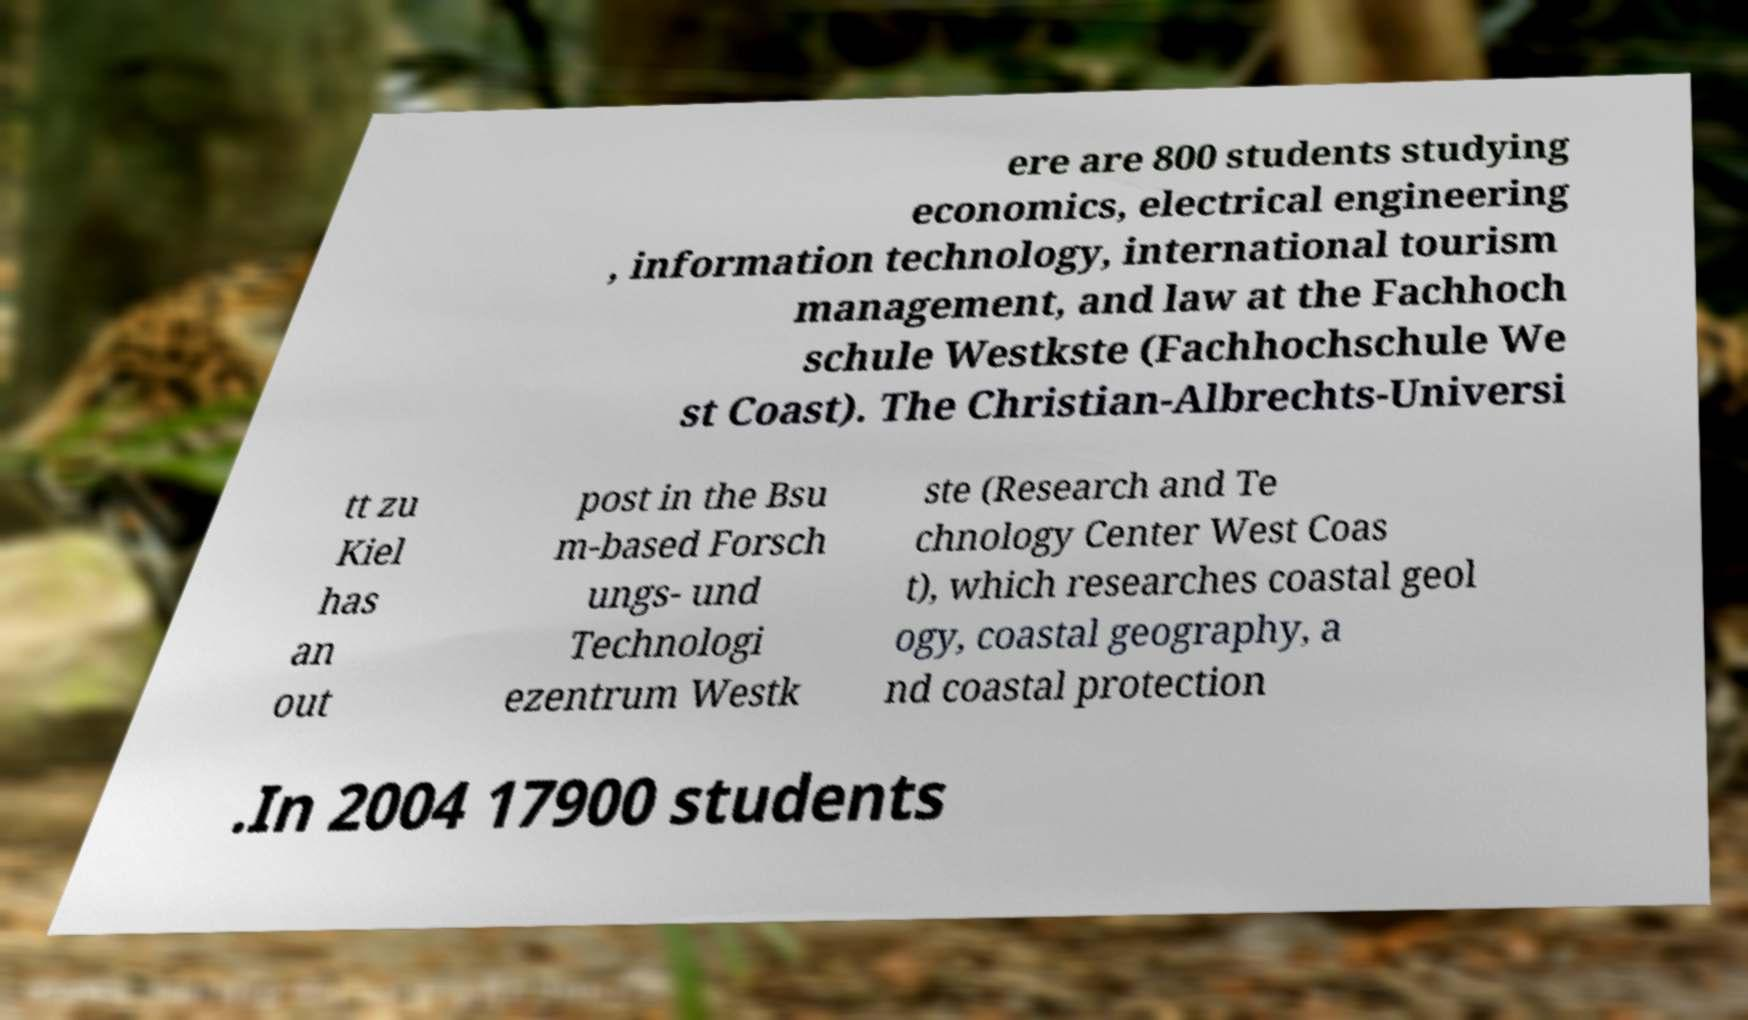Please read and relay the text visible in this image. What does it say? ere are 800 students studying economics, electrical engineering , information technology, international tourism management, and law at the Fachhoch schule Westkste (Fachhochschule We st Coast). The Christian-Albrechts-Universi tt zu Kiel has an out post in the Bsu m-based Forsch ungs- und Technologi ezentrum Westk ste (Research and Te chnology Center West Coas t), which researches coastal geol ogy, coastal geography, a nd coastal protection .In 2004 17900 students 